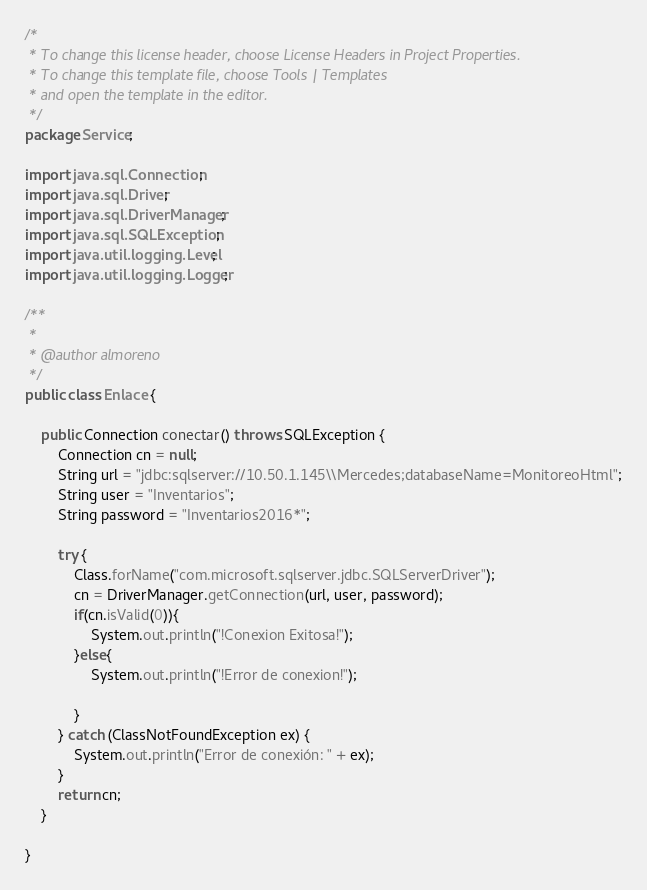Convert code to text. <code><loc_0><loc_0><loc_500><loc_500><_Java_>/*
 * To change this license header, choose License Headers in Project Properties.
 * To change this template file, choose Tools | Templates
 * and open the template in the editor.
 */
package Service;

import java.sql.Connection;
import java.sql.Driver;
import java.sql.DriverManager;
import java.sql.SQLException;
import java.util.logging.Level;
import java.util.logging.Logger;

/**
 *
 * @author almoreno
 */
public class Enlace {

    public Connection conectar() throws SQLException {
        Connection cn = null;
        String url = "jdbc:sqlserver://10.50.1.145\\Mercedes;databaseName=MonitoreoHtml";
        String user = "Inventarios";
        String password = "Inventarios2016*";

        try {
            Class.forName("com.microsoft.sqlserver.jdbc.SQLServerDriver");
            cn = DriverManager.getConnection(url, user, password);
            if(cn.isValid(0)){
                System.out.println("!Conexion Exitosa!");
            }else{
                System.out.println("!Error de conexion!");
                
            }
        } catch (ClassNotFoundException ex) {
            System.out.println("Error de conexión: " + ex);
        }
        return cn;
    }

}
</code> 